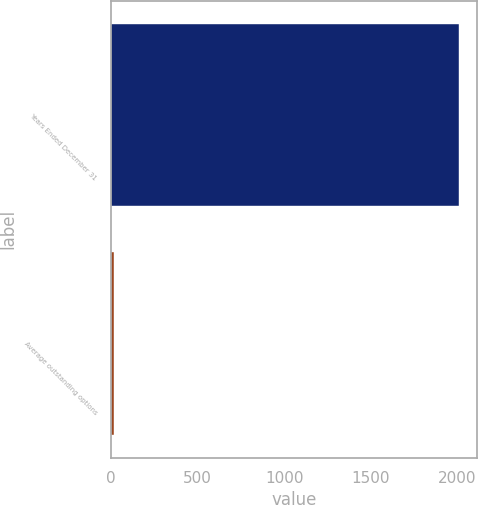<chart> <loc_0><loc_0><loc_500><loc_500><bar_chart><fcel>Years Ended December 31<fcel>Average outstanding options<nl><fcel>2012<fcel>16<nl></chart> 